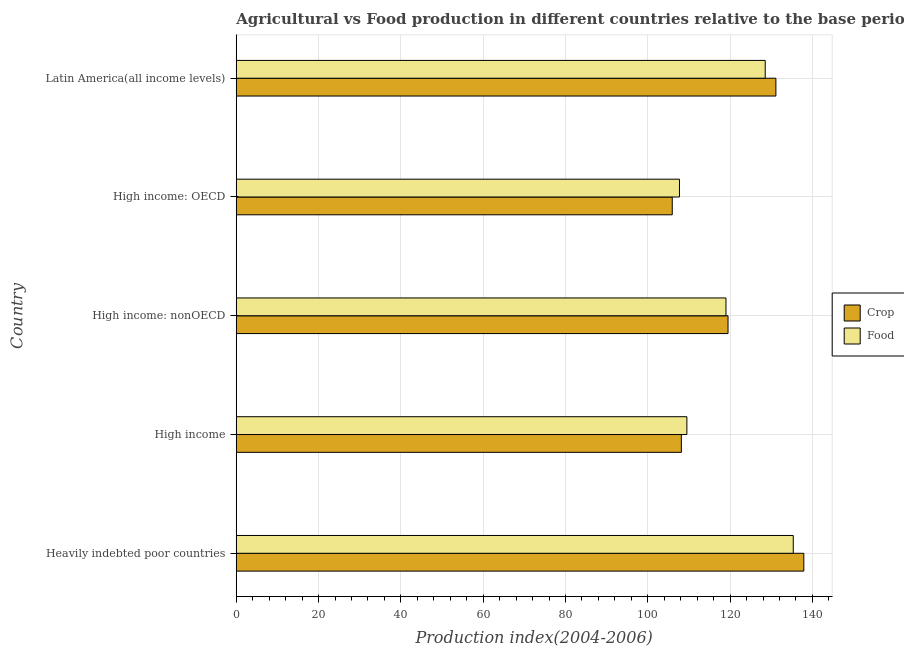How many different coloured bars are there?
Your answer should be very brief. 2. How many groups of bars are there?
Your response must be concise. 5. What is the label of the 2nd group of bars from the top?
Your response must be concise. High income: OECD. What is the food production index in High income: OECD?
Your answer should be very brief. 107.7. Across all countries, what is the maximum food production index?
Offer a terse response. 135.35. Across all countries, what is the minimum crop production index?
Offer a terse response. 105.95. In which country was the crop production index maximum?
Ensure brevity in your answer.  Heavily indebted poor countries. In which country was the crop production index minimum?
Offer a terse response. High income: OECD. What is the total crop production index in the graph?
Your answer should be compact. 602.67. What is the difference between the food production index in High income and that in High income: nonOECD?
Provide a short and direct response. -9.5. What is the difference between the crop production index in High income and the food production index in High income: nonOECD?
Provide a short and direct response. -10.84. What is the average crop production index per country?
Ensure brevity in your answer.  120.53. What is the difference between the food production index and crop production index in High income?
Provide a succinct answer. 1.34. What is the ratio of the food production index in Heavily indebted poor countries to that in High income: nonOECD?
Provide a short and direct response. 1.14. What is the difference between the highest and the second highest food production index?
Provide a short and direct response. 6.82. What is the difference between the highest and the lowest food production index?
Your answer should be compact. 27.65. What does the 2nd bar from the top in Heavily indebted poor countries represents?
Ensure brevity in your answer.  Crop. What does the 2nd bar from the bottom in High income: nonOECD represents?
Ensure brevity in your answer.  Food. How many countries are there in the graph?
Give a very brief answer. 5. Are the values on the major ticks of X-axis written in scientific E-notation?
Offer a terse response. No. Does the graph contain grids?
Offer a very short reply. Yes. How many legend labels are there?
Provide a succinct answer. 2. How are the legend labels stacked?
Your answer should be compact. Vertical. What is the title of the graph?
Offer a very short reply. Agricultural vs Food production in different countries relative to the base period 2004-2006. What is the label or title of the X-axis?
Offer a very short reply. Production index(2004-2006). What is the label or title of the Y-axis?
Provide a succinct answer. Country. What is the Production index(2004-2006) in Crop in Heavily indebted poor countries?
Provide a short and direct response. 137.92. What is the Production index(2004-2006) in Food in Heavily indebted poor countries?
Ensure brevity in your answer.  135.35. What is the Production index(2004-2006) in Crop in High income?
Ensure brevity in your answer.  108.16. What is the Production index(2004-2006) of Food in High income?
Your response must be concise. 109.5. What is the Production index(2004-2006) of Crop in High income: nonOECD?
Provide a short and direct response. 119.5. What is the Production index(2004-2006) in Food in High income: nonOECD?
Give a very brief answer. 119. What is the Production index(2004-2006) in Crop in High income: OECD?
Your answer should be compact. 105.95. What is the Production index(2004-2006) of Food in High income: OECD?
Provide a short and direct response. 107.7. What is the Production index(2004-2006) of Crop in Latin America(all income levels)?
Give a very brief answer. 131.13. What is the Production index(2004-2006) of Food in Latin America(all income levels)?
Offer a terse response. 128.54. Across all countries, what is the maximum Production index(2004-2006) in Crop?
Offer a terse response. 137.92. Across all countries, what is the maximum Production index(2004-2006) of Food?
Give a very brief answer. 135.35. Across all countries, what is the minimum Production index(2004-2006) in Crop?
Give a very brief answer. 105.95. Across all countries, what is the minimum Production index(2004-2006) of Food?
Your answer should be very brief. 107.7. What is the total Production index(2004-2006) of Crop in the graph?
Ensure brevity in your answer.  602.67. What is the total Production index(2004-2006) of Food in the graph?
Make the answer very short. 600.1. What is the difference between the Production index(2004-2006) of Crop in Heavily indebted poor countries and that in High income?
Ensure brevity in your answer.  29.76. What is the difference between the Production index(2004-2006) of Food in Heavily indebted poor countries and that in High income?
Ensure brevity in your answer.  25.85. What is the difference between the Production index(2004-2006) of Crop in Heavily indebted poor countries and that in High income: nonOECD?
Offer a very short reply. 18.42. What is the difference between the Production index(2004-2006) in Food in Heavily indebted poor countries and that in High income: nonOECD?
Offer a very short reply. 16.35. What is the difference between the Production index(2004-2006) of Crop in Heavily indebted poor countries and that in High income: OECD?
Your answer should be very brief. 31.97. What is the difference between the Production index(2004-2006) in Food in Heavily indebted poor countries and that in High income: OECD?
Your answer should be very brief. 27.65. What is the difference between the Production index(2004-2006) in Crop in Heavily indebted poor countries and that in Latin America(all income levels)?
Your response must be concise. 6.79. What is the difference between the Production index(2004-2006) of Food in Heavily indebted poor countries and that in Latin America(all income levels)?
Give a very brief answer. 6.82. What is the difference between the Production index(2004-2006) in Crop in High income and that in High income: nonOECD?
Ensure brevity in your answer.  -11.34. What is the difference between the Production index(2004-2006) in Food in High income and that in High income: nonOECD?
Keep it short and to the point. -9.5. What is the difference between the Production index(2004-2006) in Crop in High income and that in High income: OECD?
Ensure brevity in your answer.  2.22. What is the difference between the Production index(2004-2006) in Food in High income and that in High income: OECD?
Your answer should be very brief. 1.8. What is the difference between the Production index(2004-2006) of Crop in High income and that in Latin America(all income levels)?
Give a very brief answer. -22.97. What is the difference between the Production index(2004-2006) in Food in High income and that in Latin America(all income levels)?
Make the answer very short. -19.04. What is the difference between the Production index(2004-2006) of Crop in High income: nonOECD and that in High income: OECD?
Ensure brevity in your answer.  13.56. What is the difference between the Production index(2004-2006) of Food in High income: nonOECD and that in High income: OECD?
Keep it short and to the point. 11.3. What is the difference between the Production index(2004-2006) of Crop in High income: nonOECD and that in Latin America(all income levels)?
Provide a succinct answer. -11.63. What is the difference between the Production index(2004-2006) of Food in High income: nonOECD and that in Latin America(all income levels)?
Your answer should be compact. -9.54. What is the difference between the Production index(2004-2006) of Crop in High income: OECD and that in Latin America(all income levels)?
Make the answer very short. -25.19. What is the difference between the Production index(2004-2006) of Food in High income: OECD and that in Latin America(all income levels)?
Your answer should be compact. -20.84. What is the difference between the Production index(2004-2006) in Crop in Heavily indebted poor countries and the Production index(2004-2006) in Food in High income?
Offer a terse response. 28.42. What is the difference between the Production index(2004-2006) in Crop in Heavily indebted poor countries and the Production index(2004-2006) in Food in High income: nonOECD?
Make the answer very short. 18.92. What is the difference between the Production index(2004-2006) in Crop in Heavily indebted poor countries and the Production index(2004-2006) in Food in High income: OECD?
Ensure brevity in your answer.  30.22. What is the difference between the Production index(2004-2006) in Crop in Heavily indebted poor countries and the Production index(2004-2006) in Food in Latin America(all income levels)?
Offer a terse response. 9.38. What is the difference between the Production index(2004-2006) of Crop in High income and the Production index(2004-2006) of Food in High income: nonOECD?
Provide a short and direct response. -10.84. What is the difference between the Production index(2004-2006) of Crop in High income and the Production index(2004-2006) of Food in High income: OECD?
Keep it short and to the point. 0.46. What is the difference between the Production index(2004-2006) of Crop in High income and the Production index(2004-2006) of Food in Latin America(all income levels)?
Provide a succinct answer. -20.38. What is the difference between the Production index(2004-2006) in Crop in High income: nonOECD and the Production index(2004-2006) in Food in High income: OECD?
Offer a terse response. 11.8. What is the difference between the Production index(2004-2006) of Crop in High income: nonOECD and the Production index(2004-2006) of Food in Latin America(all income levels)?
Provide a short and direct response. -9.04. What is the difference between the Production index(2004-2006) of Crop in High income: OECD and the Production index(2004-2006) of Food in Latin America(all income levels)?
Your answer should be very brief. -22.59. What is the average Production index(2004-2006) in Crop per country?
Your response must be concise. 120.53. What is the average Production index(2004-2006) in Food per country?
Ensure brevity in your answer.  120.02. What is the difference between the Production index(2004-2006) of Crop and Production index(2004-2006) of Food in Heavily indebted poor countries?
Keep it short and to the point. 2.57. What is the difference between the Production index(2004-2006) in Crop and Production index(2004-2006) in Food in High income?
Your answer should be very brief. -1.34. What is the difference between the Production index(2004-2006) of Crop and Production index(2004-2006) of Food in High income: nonOECD?
Give a very brief answer. 0.5. What is the difference between the Production index(2004-2006) in Crop and Production index(2004-2006) in Food in High income: OECD?
Ensure brevity in your answer.  -1.76. What is the difference between the Production index(2004-2006) in Crop and Production index(2004-2006) in Food in Latin America(all income levels)?
Your answer should be very brief. 2.59. What is the ratio of the Production index(2004-2006) of Crop in Heavily indebted poor countries to that in High income?
Provide a short and direct response. 1.28. What is the ratio of the Production index(2004-2006) of Food in Heavily indebted poor countries to that in High income?
Provide a succinct answer. 1.24. What is the ratio of the Production index(2004-2006) in Crop in Heavily indebted poor countries to that in High income: nonOECD?
Keep it short and to the point. 1.15. What is the ratio of the Production index(2004-2006) in Food in Heavily indebted poor countries to that in High income: nonOECD?
Keep it short and to the point. 1.14. What is the ratio of the Production index(2004-2006) of Crop in Heavily indebted poor countries to that in High income: OECD?
Your answer should be compact. 1.3. What is the ratio of the Production index(2004-2006) in Food in Heavily indebted poor countries to that in High income: OECD?
Offer a very short reply. 1.26. What is the ratio of the Production index(2004-2006) of Crop in Heavily indebted poor countries to that in Latin America(all income levels)?
Keep it short and to the point. 1.05. What is the ratio of the Production index(2004-2006) in Food in Heavily indebted poor countries to that in Latin America(all income levels)?
Keep it short and to the point. 1.05. What is the ratio of the Production index(2004-2006) in Crop in High income to that in High income: nonOECD?
Offer a terse response. 0.91. What is the ratio of the Production index(2004-2006) in Food in High income to that in High income: nonOECD?
Your answer should be very brief. 0.92. What is the ratio of the Production index(2004-2006) of Crop in High income to that in High income: OECD?
Make the answer very short. 1.02. What is the ratio of the Production index(2004-2006) in Food in High income to that in High income: OECD?
Your answer should be very brief. 1.02. What is the ratio of the Production index(2004-2006) of Crop in High income to that in Latin America(all income levels)?
Keep it short and to the point. 0.82. What is the ratio of the Production index(2004-2006) in Food in High income to that in Latin America(all income levels)?
Give a very brief answer. 0.85. What is the ratio of the Production index(2004-2006) in Crop in High income: nonOECD to that in High income: OECD?
Make the answer very short. 1.13. What is the ratio of the Production index(2004-2006) in Food in High income: nonOECD to that in High income: OECD?
Your response must be concise. 1.1. What is the ratio of the Production index(2004-2006) of Crop in High income: nonOECD to that in Latin America(all income levels)?
Make the answer very short. 0.91. What is the ratio of the Production index(2004-2006) of Food in High income: nonOECD to that in Latin America(all income levels)?
Provide a succinct answer. 0.93. What is the ratio of the Production index(2004-2006) of Crop in High income: OECD to that in Latin America(all income levels)?
Provide a succinct answer. 0.81. What is the ratio of the Production index(2004-2006) in Food in High income: OECD to that in Latin America(all income levels)?
Provide a succinct answer. 0.84. What is the difference between the highest and the second highest Production index(2004-2006) in Crop?
Ensure brevity in your answer.  6.79. What is the difference between the highest and the second highest Production index(2004-2006) of Food?
Make the answer very short. 6.82. What is the difference between the highest and the lowest Production index(2004-2006) in Crop?
Make the answer very short. 31.97. What is the difference between the highest and the lowest Production index(2004-2006) of Food?
Your answer should be compact. 27.65. 